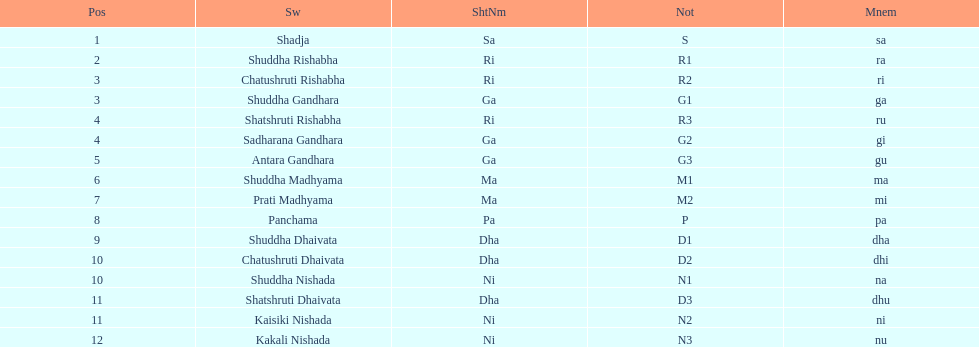On average, how many swara possess short names beginning with the letters d or g? 6. 